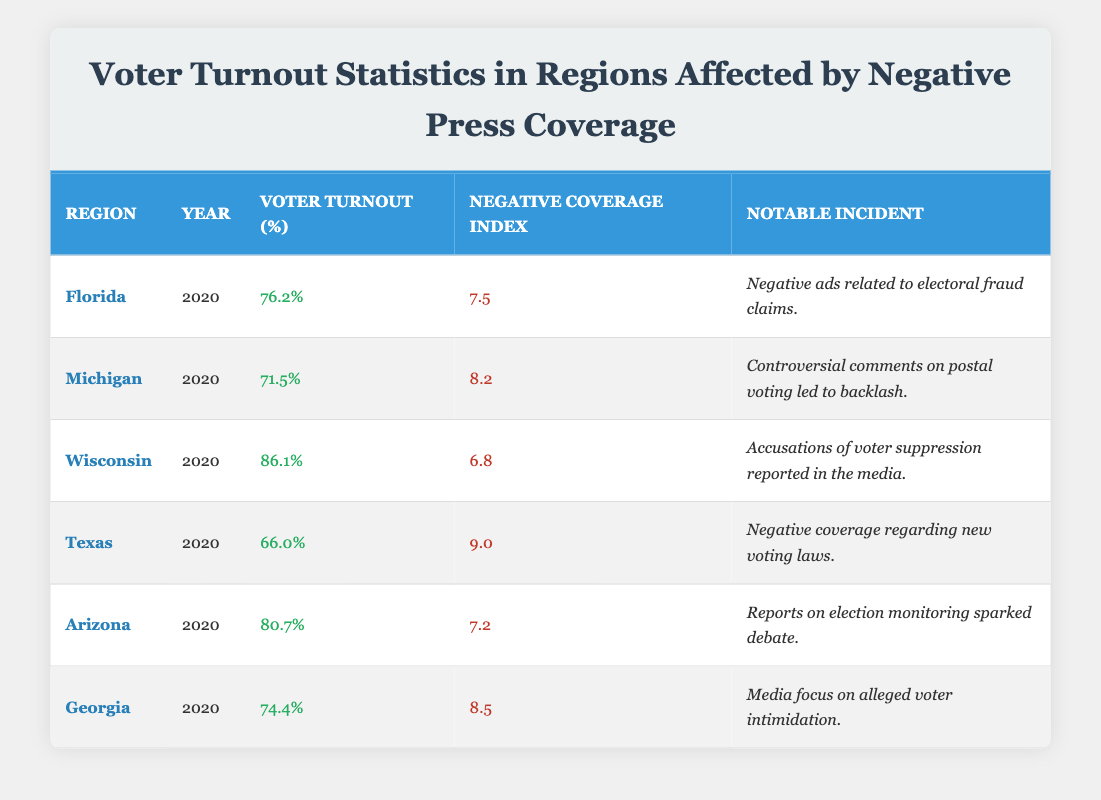What is the voter turnout percentage in Texas? The voter turnout percentage for Texas in 2020 is listed directly in the table. You can find it under the "Voter Turnout (%)" column.
Answer: 66.0% Which region had the highest negative coverage index? By examining the "Negative Coverage Index" column, I see that Texas has a negative coverage index of 9.0, which is higher than all other regions listed.
Answer: Texas What is the average voter turnout percentage of the listed regions? To find the average, sum the voter turnout percentages: (76.2 + 71.5 + 86.1 + 66.0 + 80.7 + 74.4) = 455.0. Then divide by the number of regions (6), which gives 455.0 / 6 ≈ 75.83.
Answer: 75.83% Did Georgia have a notable incident regarding voter intimidation? The table states that the notable incident for Georgia involved the media focusing on alleged voter intimidation. This confirms that it did occur.
Answer: Yes Which region had a voter turnout percentage lower than the average? Based on the average calculated previously (75.83), I compare each region: Texas (66.0) is lower than the average, while the others are not.
Answer: Texas What is the difference in voter turnout percentage between Wisconsin and Michigan? From the table, Wisconsin's turnout is 86.1% and Michigan's is 71.5%. The difference is calculated as 86.1 - 71.5 = 14.6%.
Answer: 14.6% Was any notable incident mentioned for Florida? The table clearly states that Florida had negative ads related to electoral fraud claims as a notable incident. Thus, there is indeed an incident mentioned.
Answer: Yes Which region with notable incidents related to electoral fraud had a turnout higher than 75%? The regions I need to check are those that mention electoral fraud: Florida (76.2%) and no others relate specifically to that incident. 76.2% is higher than 75%.
Answer: Florida In which region was the negative coverage index the lowest? By checking the "Negative Coverage Index" values, Wisconsin has the lowest index of 6.8 among the listed regions.
Answer: Wisconsin 